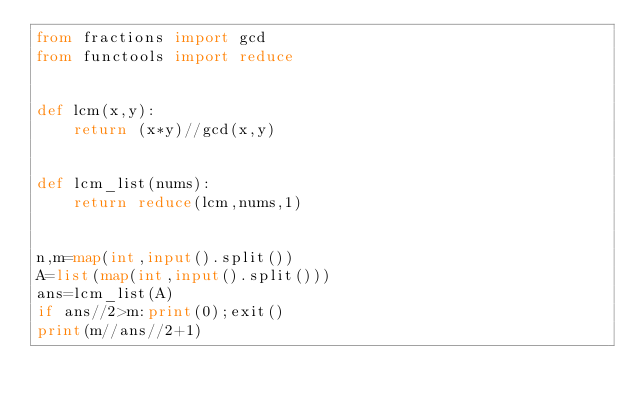Convert code to text. <code><loc_0><loc_0><loc_500><loc_500><_Python_>from fractions import gcd
from functools import reduce


def lcm(x,y):
    return (x*y)//gcd(x,y)


def lcm_list(nums):
    return reduce(lcm,nums,1)


n,m=map(int,input().split())
A=list(map(int,input().split()))
ans=lcm_list(A)
if ans//2>m:print(0);exit()
print(m//ans//2+1)</code> 